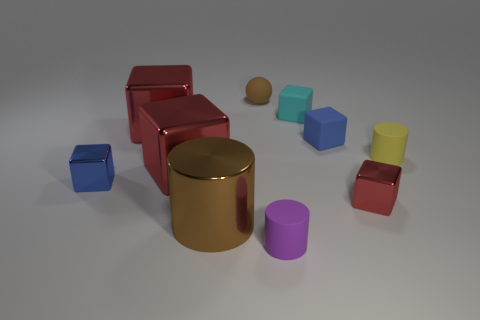What number of objects are either small rubber things that are on the left side of the purple cylinder or tiny brown objects?
Your response must be concise. 1. There is a red cube right of the brown object that is in front of the blue shiny cube; how many cubes are behind it?
Your answer should be compact. 5. Is there anything else that is the same size as the brown matte sphere?
Offer a terse response. Yes. The red shiny thing in front of the tiny shiny thing to the left of the rubber thing that is behind the cyan object is what shape?
Provide a short and direct response. Cube. How many other things are there of the same color as the small rubber ball?
Offer a very short reply. 1. There is a tiny rubber object that is in front of the red metal cube that is to the right of the big brown metallic thing; what is its shape?
Provide a short and direct response. Cylinder. What number of red metal things are left of the cyan rubber thing?
Your answer should be very brief. 2. Is there a cyan block that has the same material as the brown cylinder?
Provide a short and direct response. No. What material is the brown object that is the same size as the blue matte object?
Provide a succinct answer. Rubber. What is the size of the thing that is to the right of the brown matte thing and left of the cyan object?
Your response must be concise. Small. 